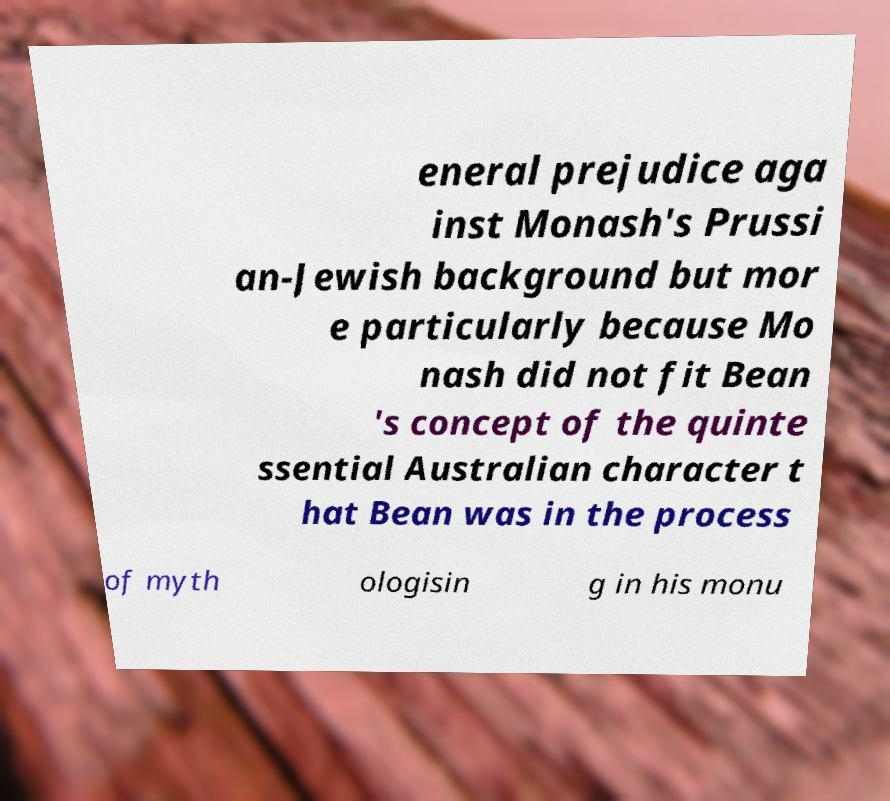Could you extract and type out the text from this image? eneral prejudice aga inst Monash's Prussi an-Jewish background but mor e particularly because Mo nash did not fit Bean 's concept of the quinte ssential Australian character t hat Bean was in the process of myth ologisin g in his monu 